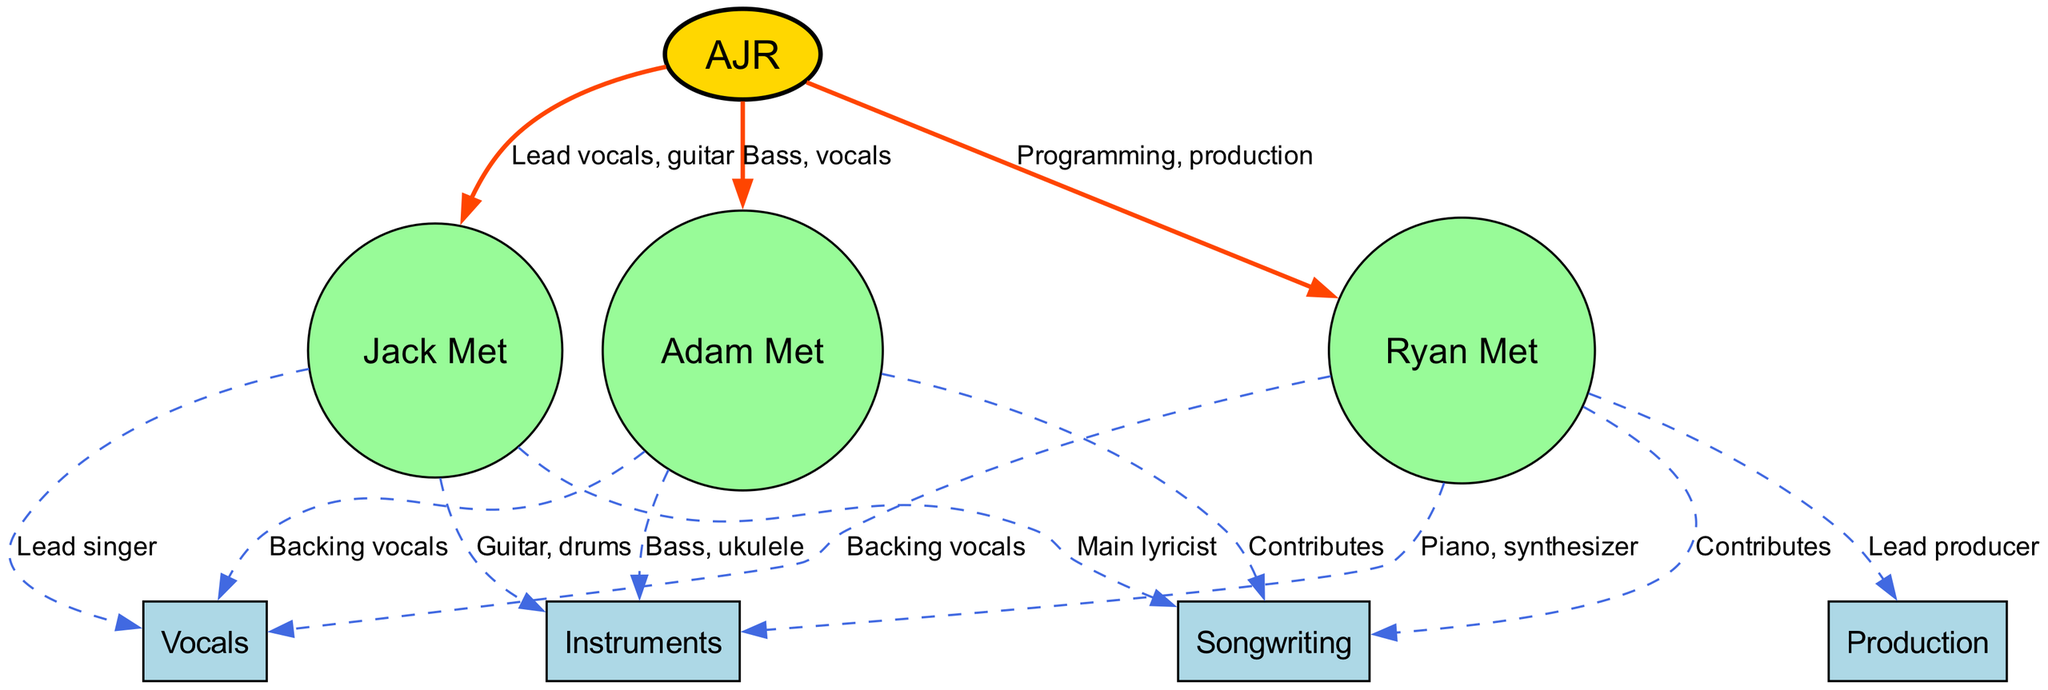What are Adam Met's contributions to AJR? Adam Met contributes as a bassist and provides backing vocals, and he also plays instruments like bass and ukulele. These roles are directly linked to the node “AJR” showing Adam’s involvement.
Answer: Bass, vocals Who is the main lyricist of AJR? The main lyricist for AJR is Jack Met, indicated by the connection from Jack to the node “Songwriting” as the main lyricist.
Answer: Jack Met How many members are in AJR? There are three members in AJR: Adam Met, Jack Met, and Ryan Met. This is evident from counting the individual nodes connected to "AJR."
Answer: Three What role does Ryan Met play in AJR's production? Ryan Met is identified as the lead producer in the diagram, which is explicitly stated from the edge connecting Ryan to the "Production" node.
Answer: Lead producer What instruments does Jack Met play? Jack Met plays guitar and drums, as indicated by the edge linking him to the "Instruments" node with that specific label.
Answer: Guitar, drums What type of edge connects AJR to Jack Met? The edge connecting AJR to Jack Met is colored orange and labeled with "Lead vocals, guitar," indicating the type of relationship.
Answer: Orange Which member of AJR is responsible for programming? Ryan Met is responsible for programming, shown by the edge that connects Ryan to "Programming" indicating his specific contribution.
Answer: Ryan Met How many types of contributions does Adam Met provide? Adam Met provides contributions in three types: songwriting, vocals, and instrumentation, indicated by multiple edges originating from his node.
Answer: Three What is the relationship between Ryan Met and the "Instruments" category? Ryan Met plays the piano and synthesizer, which connects him to the "Instruments" node, demonstrating his role in playing musical instruments.
Answer: Piano, synthesizer 